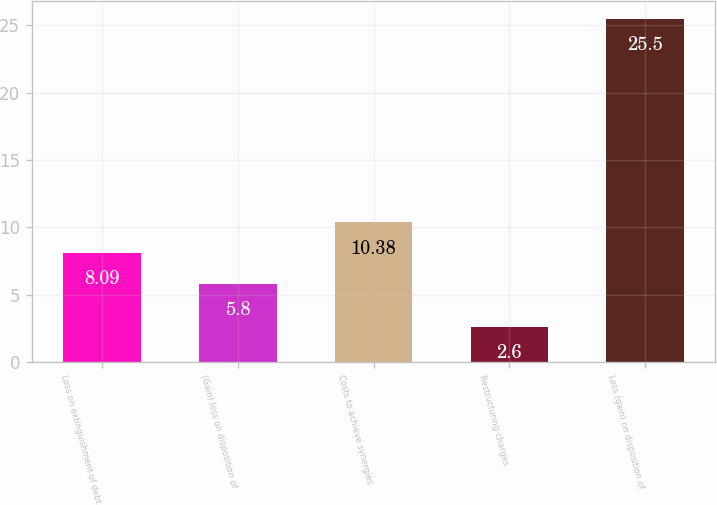Convert chart. <chart><loc_0><loc_0><loc_500><loc_500><bar_chart><fcel>Loss on extinguishment of debt<fcel>(Gain) loss on disposition of<fcel>Costs to achieve synergies<fcel>Restructuring charges<fcel>Loss (gain) on disposition of<nl><fcel>8.09<fcel>5.8<fcel>10.38<fcel>2.6<fcel>25.5<nl></chart> 